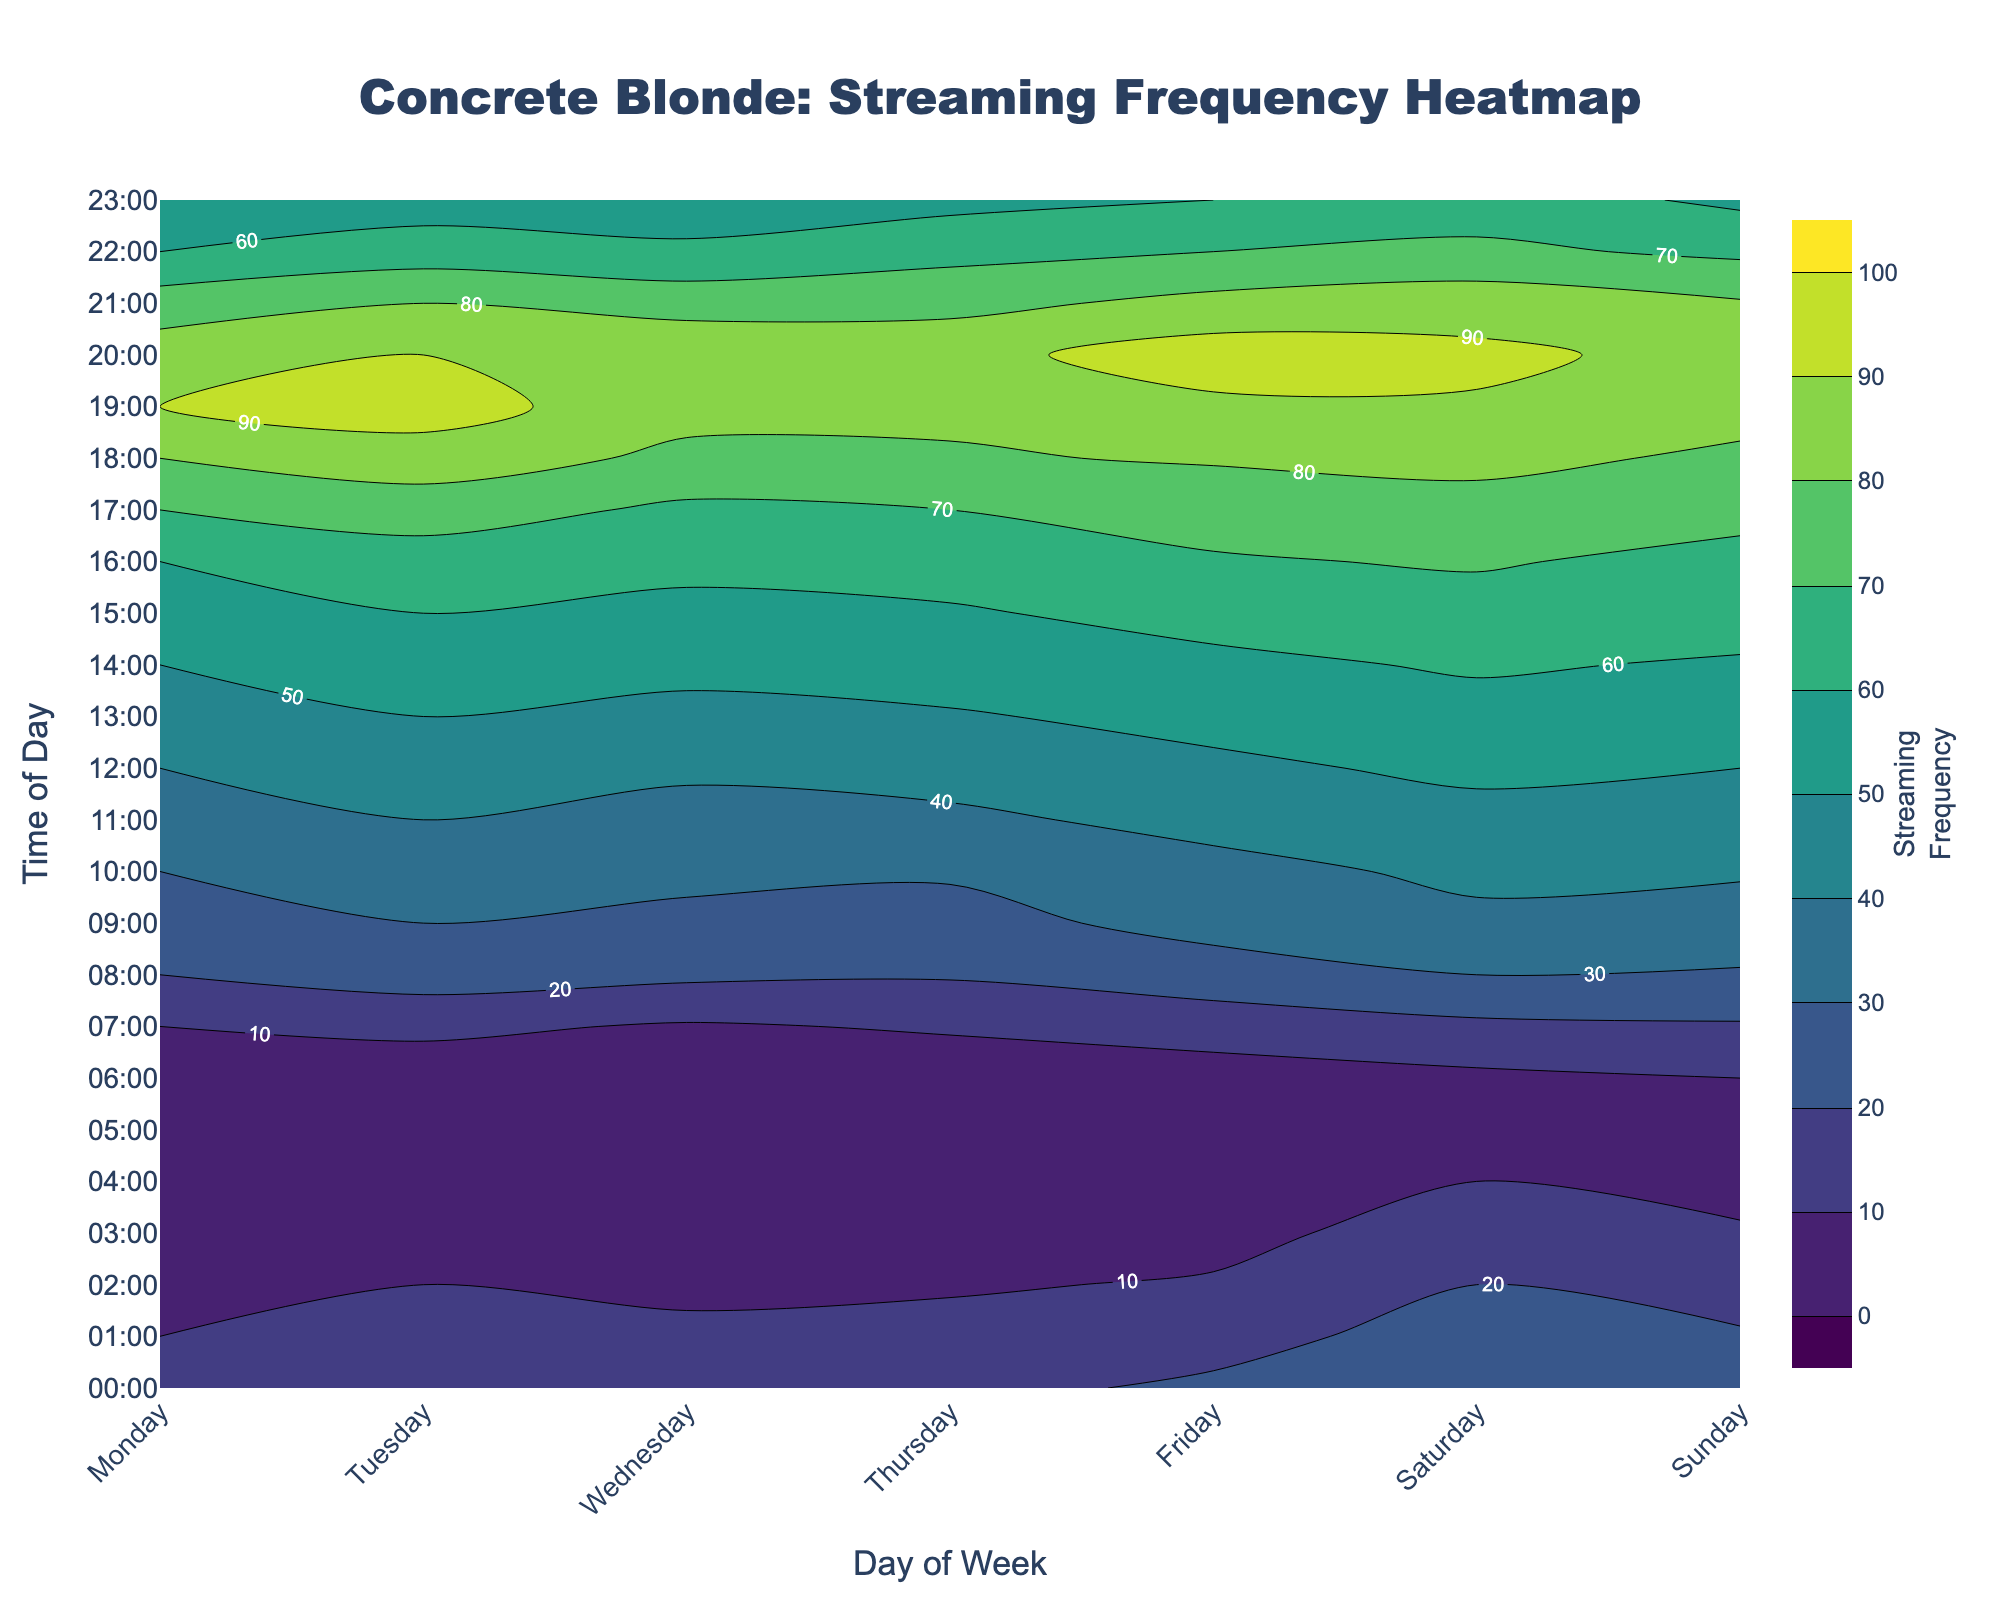What's the title of the figure? The title is usually located at the top of the figure. For this plot, it reads "Concrete Blonde: Streaming Frequency Heatmap."
Answer: Concrete Blonde: Streaming Frequency Heatmap What do the color gradients represent in the figure? Color gradients in a contour plot typically represent the varying levels of intensity or magnitude of the data—in this case, the streaming frequency of Concrete Blonde songs.
Answer: Streaming frequency At what time on Friday is the streaming frequency highest? By following the contour lines or observing the color intensity on Friday, you can determine that the highest streaming frequency occurs around 20:00 (8 PM).
Answer: 20:00 (8 PM) How does the streaming frequency on Monday at 20:00 compare to Tuesday at 20:00? By comparing the labels or color intensity at 20:00 on both days, you can see that Tuesday has a slightly higher frequency than Monday.
Answer: Higher on Tuesday During which day and time period is the lowest streaming frequency observed? By looking at the sections with the lowest color intensity or lowest contour labels, you find the minimum streaming frequency at around 04:00-05:00 on Monday.
Answer: 04:00-05:00 on Monday What is the general trend of streaming frequency throughout the week? Observing the color intensity from Monday to Sunday, the streaming frequency tends to increase towards the evening on all days, with some variability in the peaks during the weekdays and weekends.
Answer: Increases towards the evening Which time of the day shows the highest consistency in streaming frequency throughout the week? By observing the contour plot, you can see the time slots with consistent color intensity. Around 18:00-19:00, the streaming frequency is consistently high every day of the week.
Answer: 18:00-19:00 What day shows the most significant increase in streaming frequency from morning to evening? Referencing the contour labels or color change, Friday shows a noticeable increase in streaming frequency from morning (light color) to evening (dark color).
Answer: Friday What time of day on Saturday shows a significant spike in streaming frequency? By examining the plot, you can see that 20:00 on Saturday has a marked increase, indicated by darker colors.
Answer: 20:00 (8 PM) on Saturday Compare the streaming frequency at 10 AM on Wednesday and Thursday. Which day has a higher frequency? Comparing the contour lines or color gradient at 10:00, Thursday has a slightly higher streaming frequency than Wednesday.
Answer: Higher on Thursday 